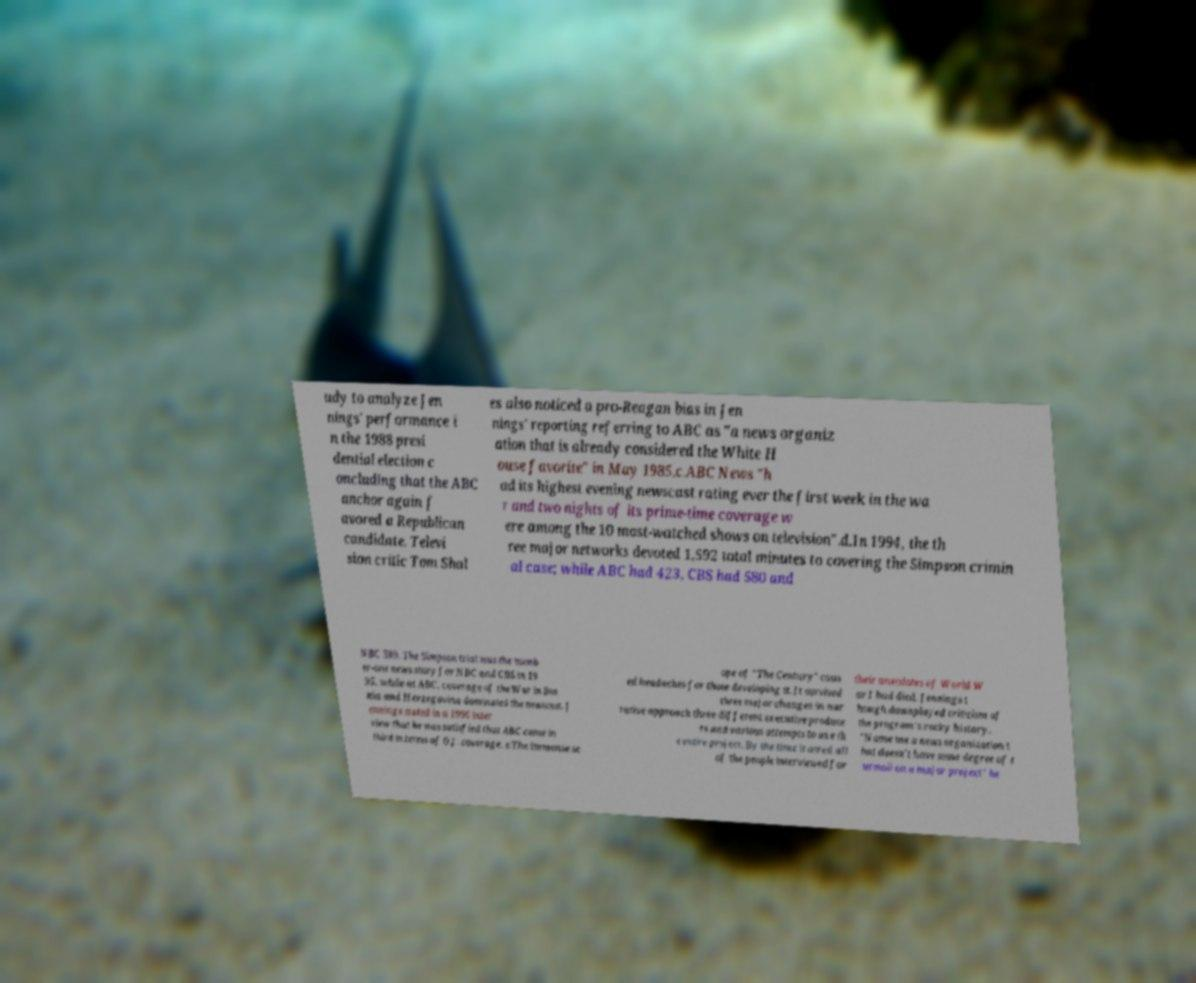Could you extract and type out the text from this image? udy to analyze Jen nings' performance i n the 1988 presi dential election c oncluding that the ABC anchor again f avored a Republican candidate. Televi sion critic Tom Shal es also noticed a pro-Reagan bias in Jen nings' reporting referring to ABC as "a news organiz ation that is already considered the White H ouse favorite" in May 1985.c.ABC News "h ad its highest evening newscast rating ever the first week in the wa r and two nights of its prime-time coverage w ere among the 10 most-watched shows on television".d.In 1994, the th ree major networks devoted 1,592 total minutes to covering the Simpson crimin al case; while ABC had 423, CBS had 580 and NBC 589. The Simpson trial was the numb er-one news story for NBC and CBS in 19 95, while at ABC, coverage of the War in Bos nia and Herzegovina dominated the newscast. J ennings stated in a 1996 inter view that he was satisfied that ABC came in third in terms of O.J. coverage. e.The immense sc ope of "The Century" caus ed headaches for those developing it. It survived three major changes in nar rative approach three different executive produce rs and various attempts to axe th e entire project. By the time it aired all of the people interviewed for their anecdotes of World W ar I had died. Jennings t hough downplayed criticism of the program's rocky history. "Name me a news organization t hat doesn't have some degree of t urmoil on a major project" he 